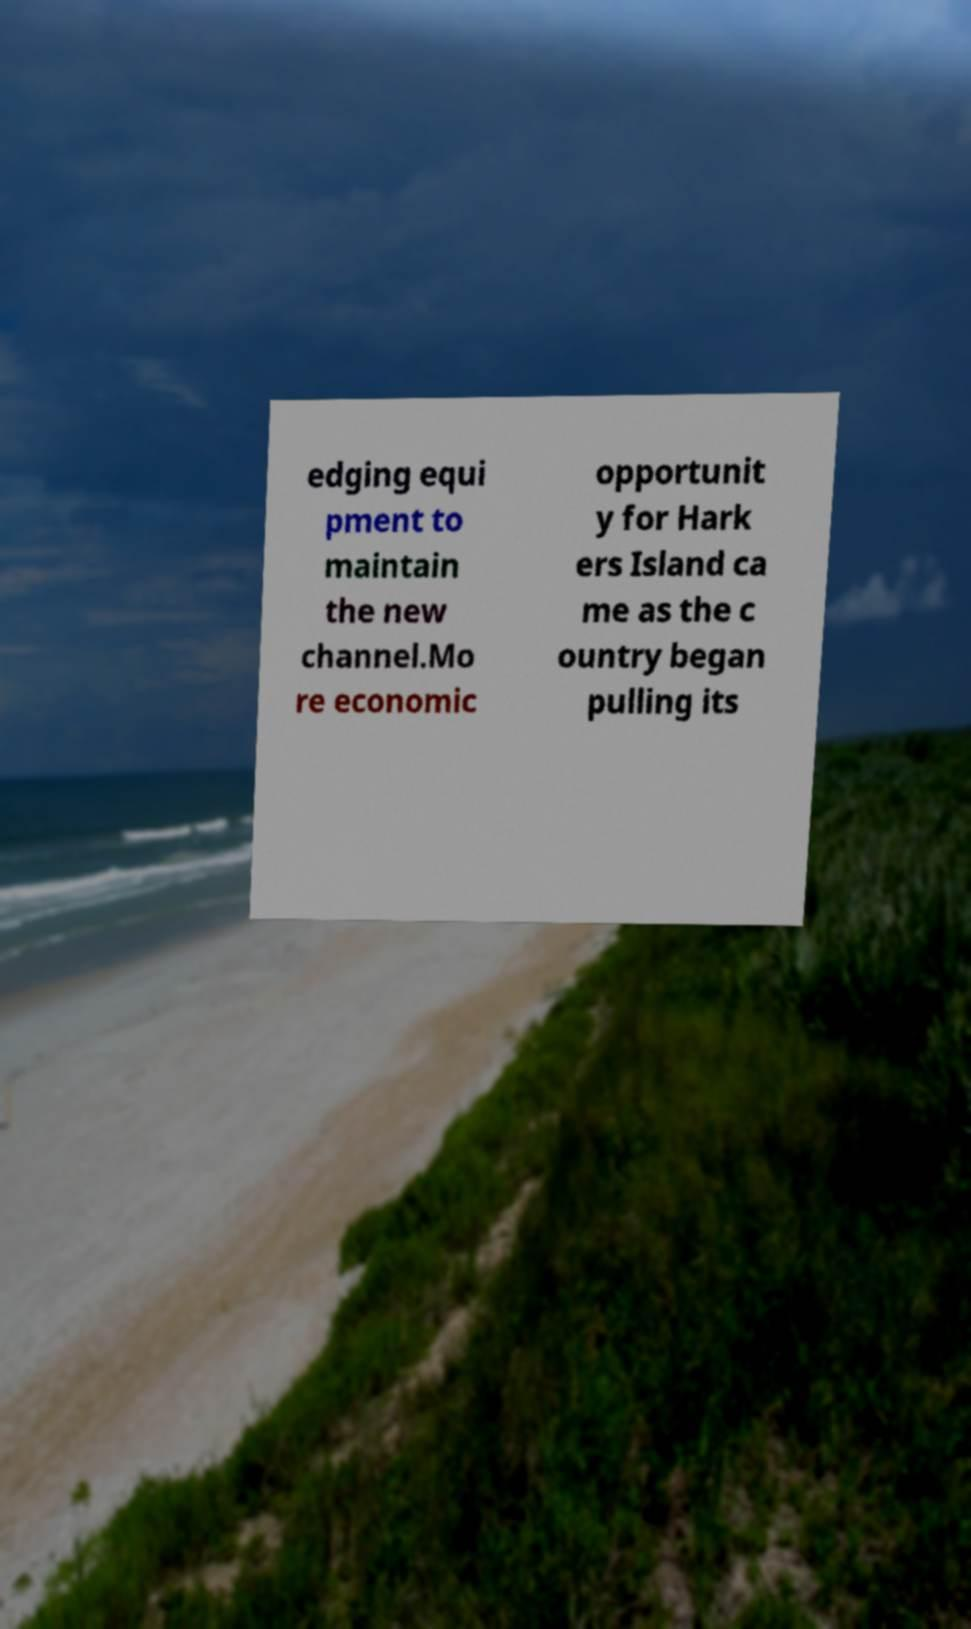Could you extract and type out the text from this image? edging equi pment to maintain the new channel.Mo re economic opportunit y for Hark ers Island ca me as the c ountry began pulling its 